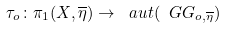<formula> <loc_0><loc_0><loc_500><loc_500>\tau _ { o } \colon \pi _ { 1 } ( X , \overline { \eta } ) \to \ a u t ( \ G G _ { o , \overline { \eta } } )</formula> 